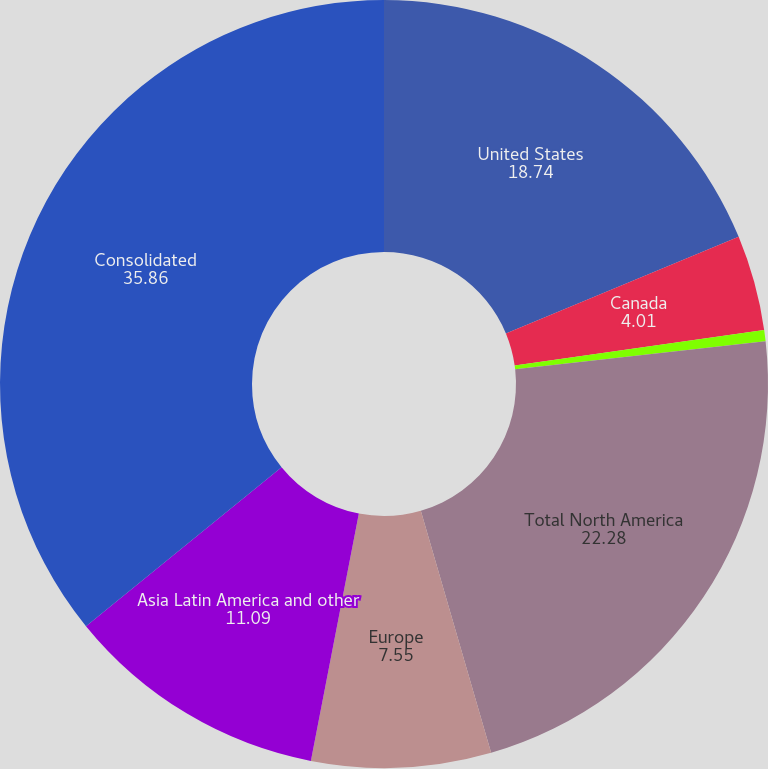Convert chart to OTSL. <chart><loc_0><loc_0><loc_500><loc_500><pie_chart><fcel>United States<fcel>Canada<fcel>Intergeographic sales<fcel>Total North America<fcel>Europe<fcel>Asia Latin America and other<fcel>Consolidated<nl><fcel>18.74%<fcel>4.01%<fcel>0.47%<fcel>22.28%<fcel>7.55%<fcel>11.09%<fcel>35.86%<nl></chart> 